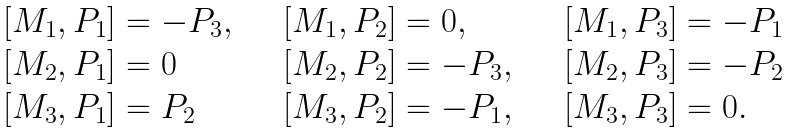<formula> <loc_0><loc_0><loc_500><loc_500>\begin{array} { l l l } \ [ M _ { 1 } , P _ { 1 } ] = - P _ { 3 } , & \quad [ M _ { 1 } , P _ { 2 } ] = 0 , & \quad [ M _ { 1 } , P _ { 3 } ] = - P _ { 1 } \\ \ [ M _ { 2 } , P _ { 1 } ] = 0 & \quad [ M _ { 2 } , P _ { 2 } ] = - P _ { 3 } , & \quad [ M _ { 2 } , P _ { 3 } ] = - P _ { 2 } \\ \ [ M _ { 3 } , P _ { 1 } ] = P _ { 2 } & \quad [ M _ { 3 } , P _ { 2 } ] = - P _ { 1 } , & \quad [ M _ { 3 } , P _ { 3 } ] = 0 . \end{array}</formula> 